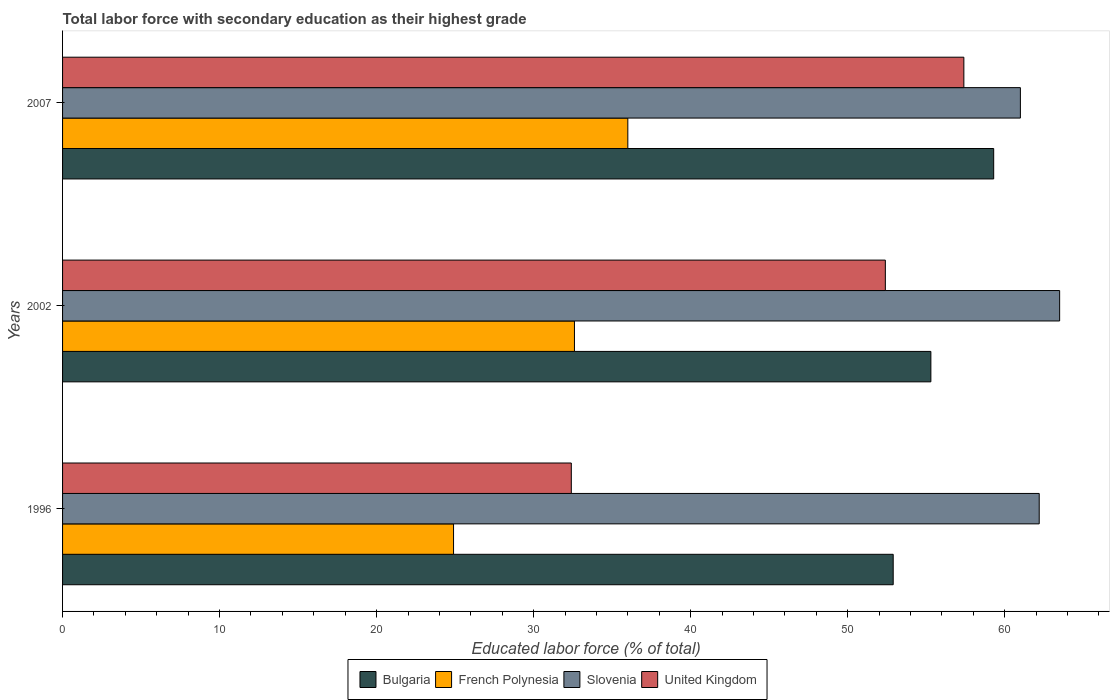How many groups of bars are there?
Offer a terse response. 3. Are the number of bars per tick equal to the number of legend labels?
Keep it short and to the point. Yes. Are the number of bars on each tick of the Y-axis equal?
Provide a short and direct response. Yes. What is the percentage of total labor force with primary education in Slovenia in 1996?
Your response must be concise. 62.2. Across all years, what is the minimum percentage of total labor force with primary education in Bulgaria?
Make the answer very short. 52.9. In which year was the percentage of total labor force with primary education in Slovenia maximum?
Your response must be concise. 2002. What is the total percentage of total labor force with primary education in Slovenia in the graph?
Keep it short and to the point. 186.7. What is the difference between the percentage of total labor force with primary education in French Polynesia in 1996 and that in 2002?
Make the answer very short. -7.7. What is the difference between the percentage of total labor force with primary education in French Polynesia in 1996 and the percentage of total labor force with primary education in Slovenia in 2002?
Give a very brief answer. -38.6. What is the average percentage of total labor force with primary education in Slovenia per year?
Ensure brevity in your answer.  62.23. In the year 2007, what is the difference between the percentage of total labor force with primary education in Bulgaria and percentage of total labor force with primary education in Slovenia?
Offer a terse response. -1.7. What is the ratio of the percentage of total labor force with primary education in Bulgaria in 2002 to that in 2007?
Provide a succinct answer. 0.93. What is the difference between the highest and the second highest percentage of total labor force with primary education in Slovenia?
Your response must be concise. 1.3. Is the sum of the percentage of total labor force with primary education in Bulgaria in 1996 and 2002 greater than the maximum percentage of total labor force with primary education in French Polynesia across all years?
Offer a terse response. Yes. Is it the case that in every year, the sum of the percentage of total labor force with primary education in United Kingdom and percentage of total labor force with primary education in Slovenia is greater than the sum of percentage of total labor force with primary education in Bulgaria and percentage of total labor force with primary education in French Polynesia?
Provide a succinct answer. No. What does the 4th bar from the top in 1996 represents?
Your response must be concise. Bulgaria. What does the 3rd bar from the bottom in 2007 represents?
Provide a short and direct response. Slovenia. Is it the case that in every year, the sum of the percentage of total labor force with primary education in United Kingdom and percentage of total labor force with primary education in Bulgaria is greater than the percentage of total labor force with primary education in Slovenia?
Your response must be concise. Yes. How many bars are there?
Provide a short and direct response. 12. What is the difference between two consecutive major ticks on the X-axis?
Keep it short and to the point. 10. Where does the legend appear in the graph?
Your answer should be compact. Bottom center. How are the legend labels stacked?
Your answer should be very brief. Horizontal. What is the title of the graph?
Your answer should be very brief. Total labor force with secondary education as their highest grade. What is the label or title of the X-axis?
Offer a very short reply. Educated labor force (% of total). What is the Educated labor force (% of total) in Bulgaria in 1996?
Provide a succinct answer. 52.9. What is the Educated labor force (% of total) of French Polynesia in 1996?
Provide a succinct answer. 24.9. What is the Educated labor force (% of total) of Slovenia in 1996?
Provide a short and direct response. 62.2. What is the Educated labor force (% of total) of United Kingdom in 1996?
Offer a very short reply. 32.4. What is the Educated labor force (% of total) in Bulgaria in 2002?
Keep it short and to the point. 55.3. What is the Educated labor force (% of total) of French Polynesia in 2002?
Make the answer very short. 32.6. What is the Educated labor force (% of total) of Slovenia in 2002?
Make the answer very short. 63.5. What is the Educated labor force (% of total) of United Kingdom in 2002?
Provide a short and direct response. 52.4. What is the Educated labor force (% of total) of Bulgaria in 2007?
Provide a short and direct response. 59.3. What is the Educated labor force (% of total) of French Polynesia in 2007?
Your response must be concise. 36. What is the Educated labor force (% of total) in Slovenia in 2007?
Your answer should be compact. 61. What is the Educated labor force (% of total) of United Kingdom in 2007?
Provide a short and direct response. 57.4. Across all years, what is the maximum Educated labor force (% of total) of Bulgaria?
Offer a terse response. 59.3. Across all years, what is the maximum Educated labor force (% of total) of Slovenia?
Offer a very short reply. 63.5. Across all years, what is the maximum Educated labor force (% of total) of United Kingdom?
Give a very brief answer. 57.4. Across all years, what is the minimum Educated labor force (% of total) of Bulgaria?
Provide a succinct answer. 52.9. Across all years, what is the minimum Educated labor force (% of total) of French Polynesia?
Offer a terse response. 24.9. Across all years, what is the minimum Educated labor force (% of total) of United Kingdom?
Give a very brief answer. 32.4. What is the total Educated labor force (% of total) of Bulgaria in the graph?
Give a very brief answer. 167.5. What is the total Educated labor force (% of total) in French Polynesia in the graph?
Give a very brief answer. 93.5. What is the total Educated labor force (% of total) in Slovenia in the graph?
Your response must be concise. 186.7. What is the total Educated labor force (% of total) of United Kingdom in the graph?
Your response must be concise. 142.2. What is the difference between the Educated labor force (% of total) in Bulgaria in 1996 and that in 2002?
Offer a terse response. -2.4. What is the difference between the Educated labor force (% of total) of Bulgaria in 2002 and that in 2007?
Offer a very short reply. -4. What is the difference between the Educated labor force (% of total) of French Polynesia in 2002 and that in 2007?
Offer a terse response. -3.4. What is the difference between the Educated labor force (% of total) in United Kingdom in 2002 and that in 2007?
Your answer should be very brief. -5. What is the difference between the Educated labor force (% of total) of Bulgaria in 1996 and the Educated labor force (% of total) of French Polynesia in 2002?
Keep it short and to the point. 20.3. What is the difference between the Educated labor force (% of total) of Bulgaria in 1996 and the Educated labor force (% of total) of Slovenia in 2002?
Provide a succinct answer. -10.6. What is the difference between the Educated labor force (% of total) of Bulgaria in 1996 and the Educated labor force (% of total) of United Kingdom in 2002?
Provide a short and direct response. 0.5. What is the difference between the Educated labor force (% of total) of French Polynesia in 1996 and the Educated labor force (% of total) of Slovenia in 2002?
Make the answer very short. -38.6. What is the difference between the Educated labor force (% of total) of French Polynesia in 1996 and the Educated labor force (% of total) of United Kingdom in 2002?
Your answer should be compact. -27.5. What is the difference between the Educated labor force (% of total) in Slovenia in 1996 and the Educated labor force (% of total) in United Kingdom in 2002?
Provide a short and direct response. 9.8. What is the difference between the Educated labor force (% of total) of Bulgaria in 1996 and the Educated labor force (% of total) of Slovenia in 2007?
Offer a very short reply. -8.1. What is the difference between the Educated labor force (% of total) of Bulgaria in 1996 and the Educated labor force (% of total) of United Kingdom in 2007?
Provide a succinct answer. -4.5. What is the difference between the Educated labor force (% of total) in French Polynesia in 1996 and the Educated labor force (% of total) in Slovenia in 2007?
Offer a terse response. -36.1. What is the difference between the Educated labor force (% of total) of French Polynesia in 1996 and the Educated labor force (% of total) of United Kingdom in 2007?
Give a very brief answer. -32.5. What is the difference between the Educated labor force (% of total) of Bulgaria in 2002 and the Educated labor force (% of total) of French Polynesia in 2007?
Offer a very short reply. 19.3. What is the difference between the Educated labor force (% of total) in Bulgaria in 2002 and the Educated labor force (% of total) in Slovenia in 2007?
Keep it short and to the point. -5.7. What is the difference between the Educated labor force (% of total) in Bulgaria in 2002 and the Educated labor force (% of total) in United Kingdom in 2007?
Provide a short and direct response. -2.1. What is the difference between the Educated labor force (% of total) of French Polynesia in 2002 and the Educated labor force (% of total) of Slovenia in 2007?
Your answer should be compact. -28.4. What is the difference between the Educated labor force (% of total) of French Polynesia in 2002 and the Educated labor force (% of total) of United Kingdom in 2007?
Provide a succinct answer. -24.8. What is the difference between the Educated labor force (% of total) in Slovenia in 2002 and the Educated labor force (% of total) in United Kingdom in 2007?
Offer a very short reply. 6.1. What is the average Educated labor force (% of total) of Bulgaria per year?
Make the answer very short. 55.83. What is the average Educated labor force (% of total) in French Polynesia per year?
Your response must be concise. 31.17. What is the average Educated labor force (% of total) in Slovenia per year?
Make the answer very short. 62.23. What is the average Educated labor force (% of total) in United Kingdom per year?
Provide a short and direct response. 47.4. In the year 1996, what is the difference between the Educated labor force (% of total) in Bulgaria and Educated labor force (% of total) in Slovenia?
Offer a terse response. -9.3. In the year 1996, what is the difference between the Educated labor force (% of total) in Bulgaria and Educated labor force (% of total) in United Kingdom?
Ensure brevity in your answer.  20.5. In the year 1996, what is the difference between the Educated labor force (% of total) in French Polynesia and Educated labor force (% of total) in Slovenia?
Your response must be concise. -37.3. In the year 1996, what is the difference between the Educated labor force (% of total) in French Polynesia and Educated labor force (% of total) in United Kingdom?
Your answer should be compact. -7.5. In the year 1996, what is the difference between the Educated labor force (% of total) of Slovenia and Educated labor force (% of total) of United Kingdom?
Offer a very short reply. 29.8. In the year 2002, what is the difference between the Educated labor force (% of total) in Bulgaria and Educated labor force (% of total) in French Polynesia?
Offer a terse response. 22.7. In the year 2002, what is the difference between the Educated labor force (% of total) in Bulgaria and Educated labor force (% of total) in Slovenia?
Make the answer very short. -8.2. In the year 2002, what is the difference between the Educated labor force (% of total) in Bulgaria and Educated labor force (% of total) in United Kingdom?
Ensure brevity in your answer.  2.9. In the year 2002, what is the difference between the Educated labor force (% of total) of French Polynesia and Educated labor force (% of total) of Slovenia?
Keep it short and to the point. -30.9. In the year 2002, what is the difference between the Educated labor force (% of total) of French Polynesia and Educated labor force (% of total) of United Kingdom?
Ensure brevity in your answer.  -19.8. In the year 2002, what is the difference between the Educated labor force (% of total) in Slovenia and Educated labor force (% of total) in United Kingdom?
Offer a terse response. 11.1. In the year 2007, what is the difference between the Educated labor force (% of total) of Bulgaria and Educated labor force (% of total) of French Polynesia?
Offer a terse response. 23.3. In the year 2007, what is the difference between the Educated labor force (% of total) in French Polynesia and Educated labor force (% of total) in Slovenia?
Provide a succinct answer. -25. In the year 2007, what is the difference between the Educated labor force (% of total) in French Polynesia and Educated labor force (% of total) in United Kingdom?
Offer a very short reply. -21.4. What is the ratio of the Educated labor force (% of total) of Bulgaria in 1996 to that in 2002?
Your answer should be compact. 0.96. What is the ratio of the Educated labor force (% of total) of French Polynesia in 1996 to that in 2002?
Your response must be concise. 0.76. What is the ratio of the Educated labor force (% of total) in Slovenia in 1996 to that in 2002?
Offer a terse response. 0.98. What is the ratio of the Educated labor force (% of total) in United Kingdom in 1996 to that in 2002?
Your answer should be very brief. 0.62. What is the ratio of the Educated labor force (% of total) of Bulgaria in 1996 to that in 2007?
Provide a succinct answer. 0.89. What is the ratio of the Educated labor force (% of total) in French Polynesia in 1996 to that in 2007?
Provide a short and direct response. 0.69. What is the ratio of the Educated labor force (% of total) of Slovenia in 1996 to that in 2007?
Offer a terse response. 1.02. What is the ratio of the Educated labor force (% of total) of United Kingdom in 1996 to that in 2007?
Ensure brevity in your answer.  0.56. What is the ratio of the Educated labor force (% of total) of Bulgaria in 2002 to that in 2007?
Provide a short and direct response. 0.93. What is the ratio of the Educated labor force (% of total) of French Polynesia in 2002 to that in 2007?
Keep it short and to the point. 0.91. What is the ratio of the Educated labor force (% of total) of Slovenia in 2002 to that in 2007?
Your answer should be compact. 1.04. What is the ratio of the Educated labor force (% of total) in United Kingdom in 2002 to that in 2007?
Keep it short and to the point. 0.91. What is the difference between the highest and the second highest Educated labor force (% of total) in French Polynesia?
Provide a short and direct response. 3.4. What is the difference between the highest and the second highest Educated labor force (% of total) in United Kingdom?
Your answer should be compact. 5. What is the difference between the highest and the lowest Educated labor force (% of total) of French Polynesia?
Make the answer very short. 11.1. What is the difference between the highest and the lowest Educated labor force (% of total) in United Kingdom?
Provide a succinct answer. 25. 